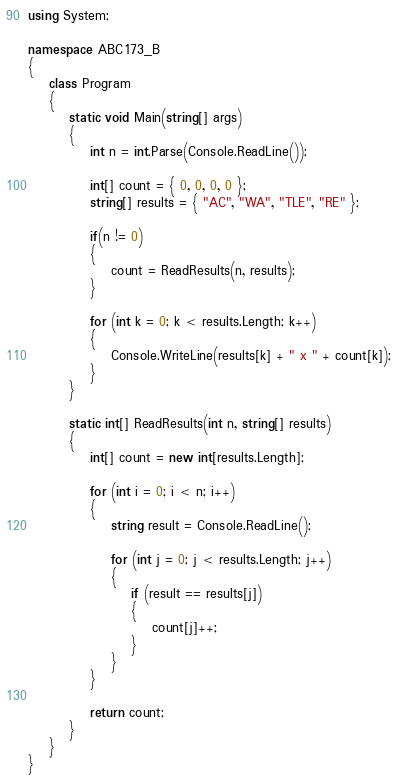<code> <loc_0><loc_0><loc_500><loc_500><_C#_>using System;

namespace ABC173_B
{
    class Program
    {
        static void Main(string[] args)
        {
            int n = int.Parse(Console.ReadLine());

            int[] count = { 0, 0, 0, 0 };
            string[] results = { "AC", "WA", "TLE", "RE" };

            if(n != 0)
            {
                count = ReadResults(n, results);
            }

            for (int k = 0; k < results.Length; k++)
            {
                Console.WriteLine(results[k] + " x " + count[k]);
            }
        }

        static int[] ReadResults(int n, string[] results)
        {
            int[] count = new int[results.Length];

            for (int i = 0; i < n; i++)
            {
                string result = Console.ReadLine();

                for (int j = 0; j < results.Length; j++)
                {
                    if (result == results[j])
                    {
                        count[j]++;
                    }
                }
            }

            return count;
        }
    }
}</code> 